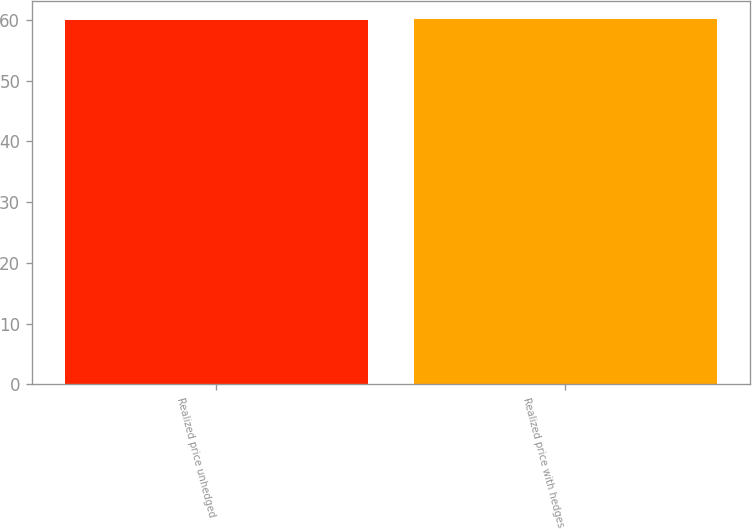Convert chart. <chart><loc_0><loc_0><loc_500><loc_500><bar_chart><fcel>Realized price unhedged<fcel>Realized price with hedges<nl><fcel>60<fcel>60.1<nl></chart> 